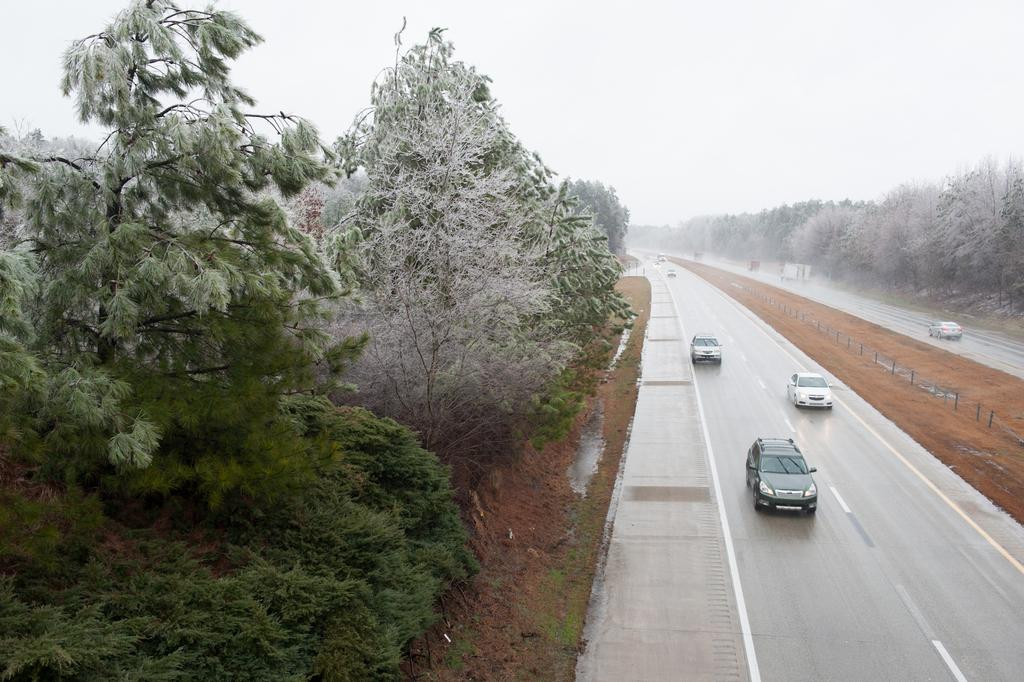What type of view is shown in the image? The image is an outside view. What can be seen on the roads in the image? There are cars on the roads in the image. On which side of the image are the cars located? The cars are on the right side of the image. What type of vegetation is present alongside the roads in the image? There are many trees on both sides of the roads in the image. What is visible at the top of the image? The sky is visible at the top of the image. What type of error message is displayed on the trees in the image? There is no error message displayed on the trees in the image; they are simply trees alongside the roads. 